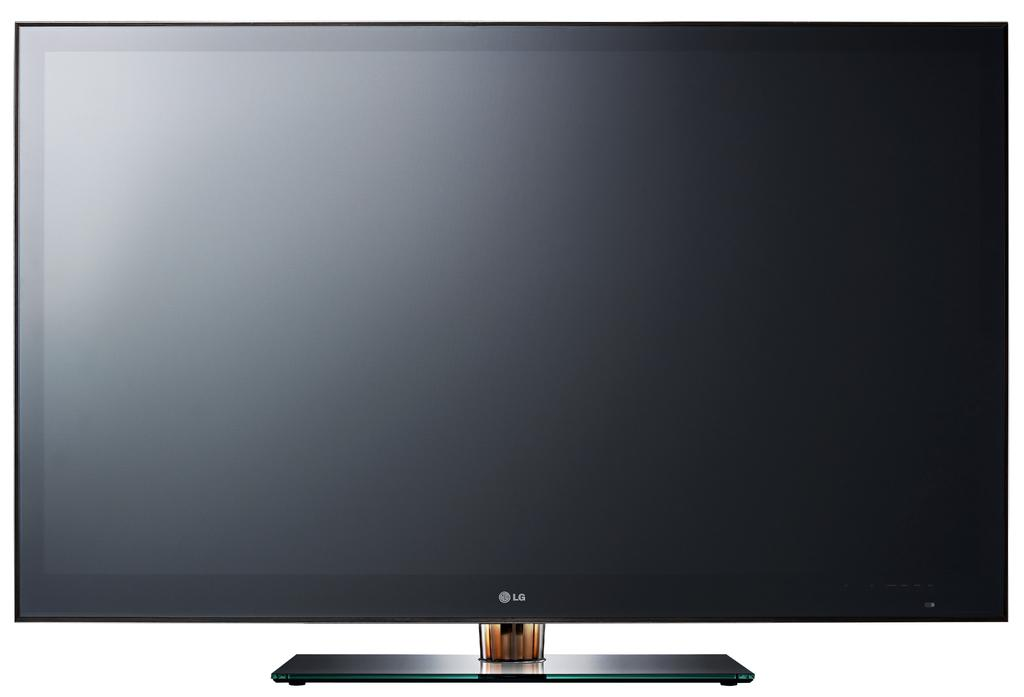Provide a one-sentence caption for the provided image. a large black thin flat screen computer monitor by lg. 